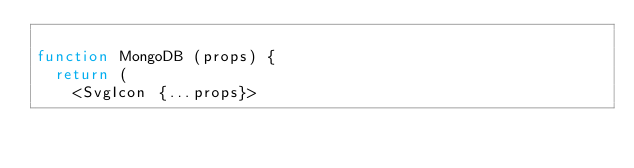Convert code to text. <code><loc_0><loc_0><loc_500><loc_500><_JavaScript_>
function MongoDB (props) {
  return (
    <SvgIcon {...props}></code> 